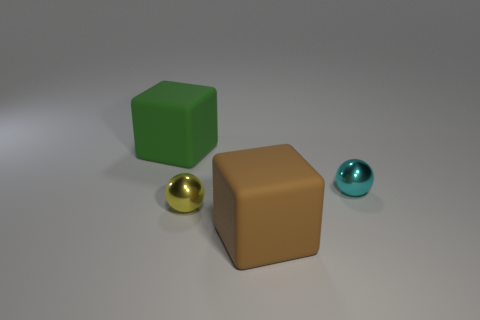Add 4 small green matte blocks. How many objects exist? 8 Subtract all small cyan metal objects. Subtract all large matte objects. How many objects are left? 1 Add 3 small shiny spheres. How many small shiny spheres are left? 5 Add 1 tiny metal balls. How many tiny metal balls exist? 3 Subtract 0 purple balls. How many objects are left? 4 